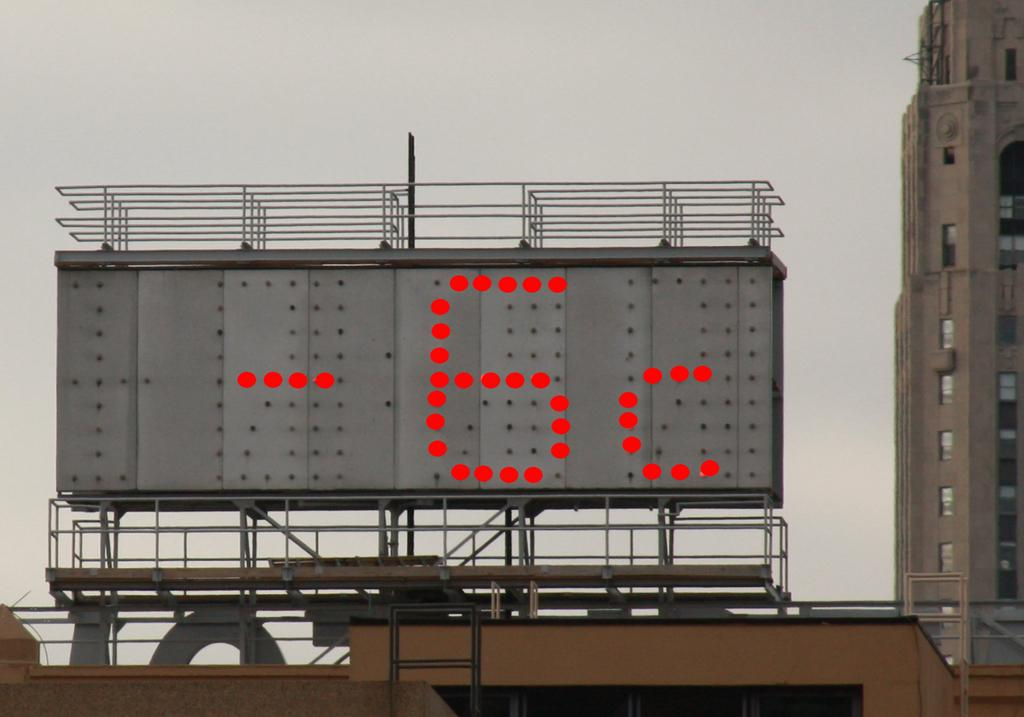<image>
Give a short and clear explanation of the subsequent image. -6c is displayed on the display sign on the board 